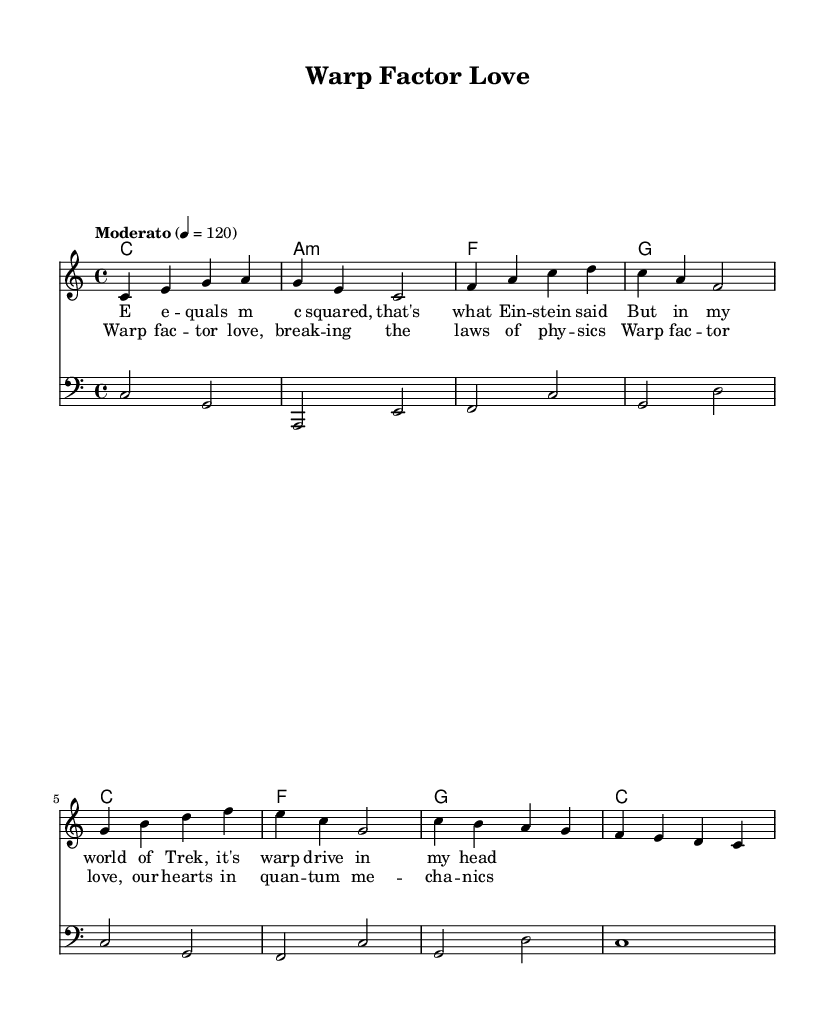What is the key signature of this music? The key signature is C major, which has no sharps or flats.
Answer: C major What is the time signature of this music? The time signature is indicated by the numbers at the beginning, showing it has four beats per measure.
Answer: 4/4 What is the tempo marking for this piece? The tempo marking states "Moderato" with a metronome marking of 120 beats per minute, indicating a moderate speed.
Answer: Moderato How many measures are in the melody section? By counting the measures indicated in the melody, there are a total of 8 measures presented.
Answer: 8 What is the first lyric line of the verse? The first line of the verse begins with "E e -- quals m c squared," which specifies the lyrics to be sung in the melody.
Answer: E e -- quals m c squared How does the chorus relate to quantum mechanics? The chorus references "quantum mechanics" alongside "Warp factor love," suggesting a playful blending of sci-fi and real-world physics concepts, indicating the intertwining themes of love and science fiction.
Answer: Quantum mechanics What type of song structure is used here? The song has a structure that includes verses and a chorus, typical of pop songs where narrative and thematic elements are presented repetitively.
Answer: Verse and chorus 